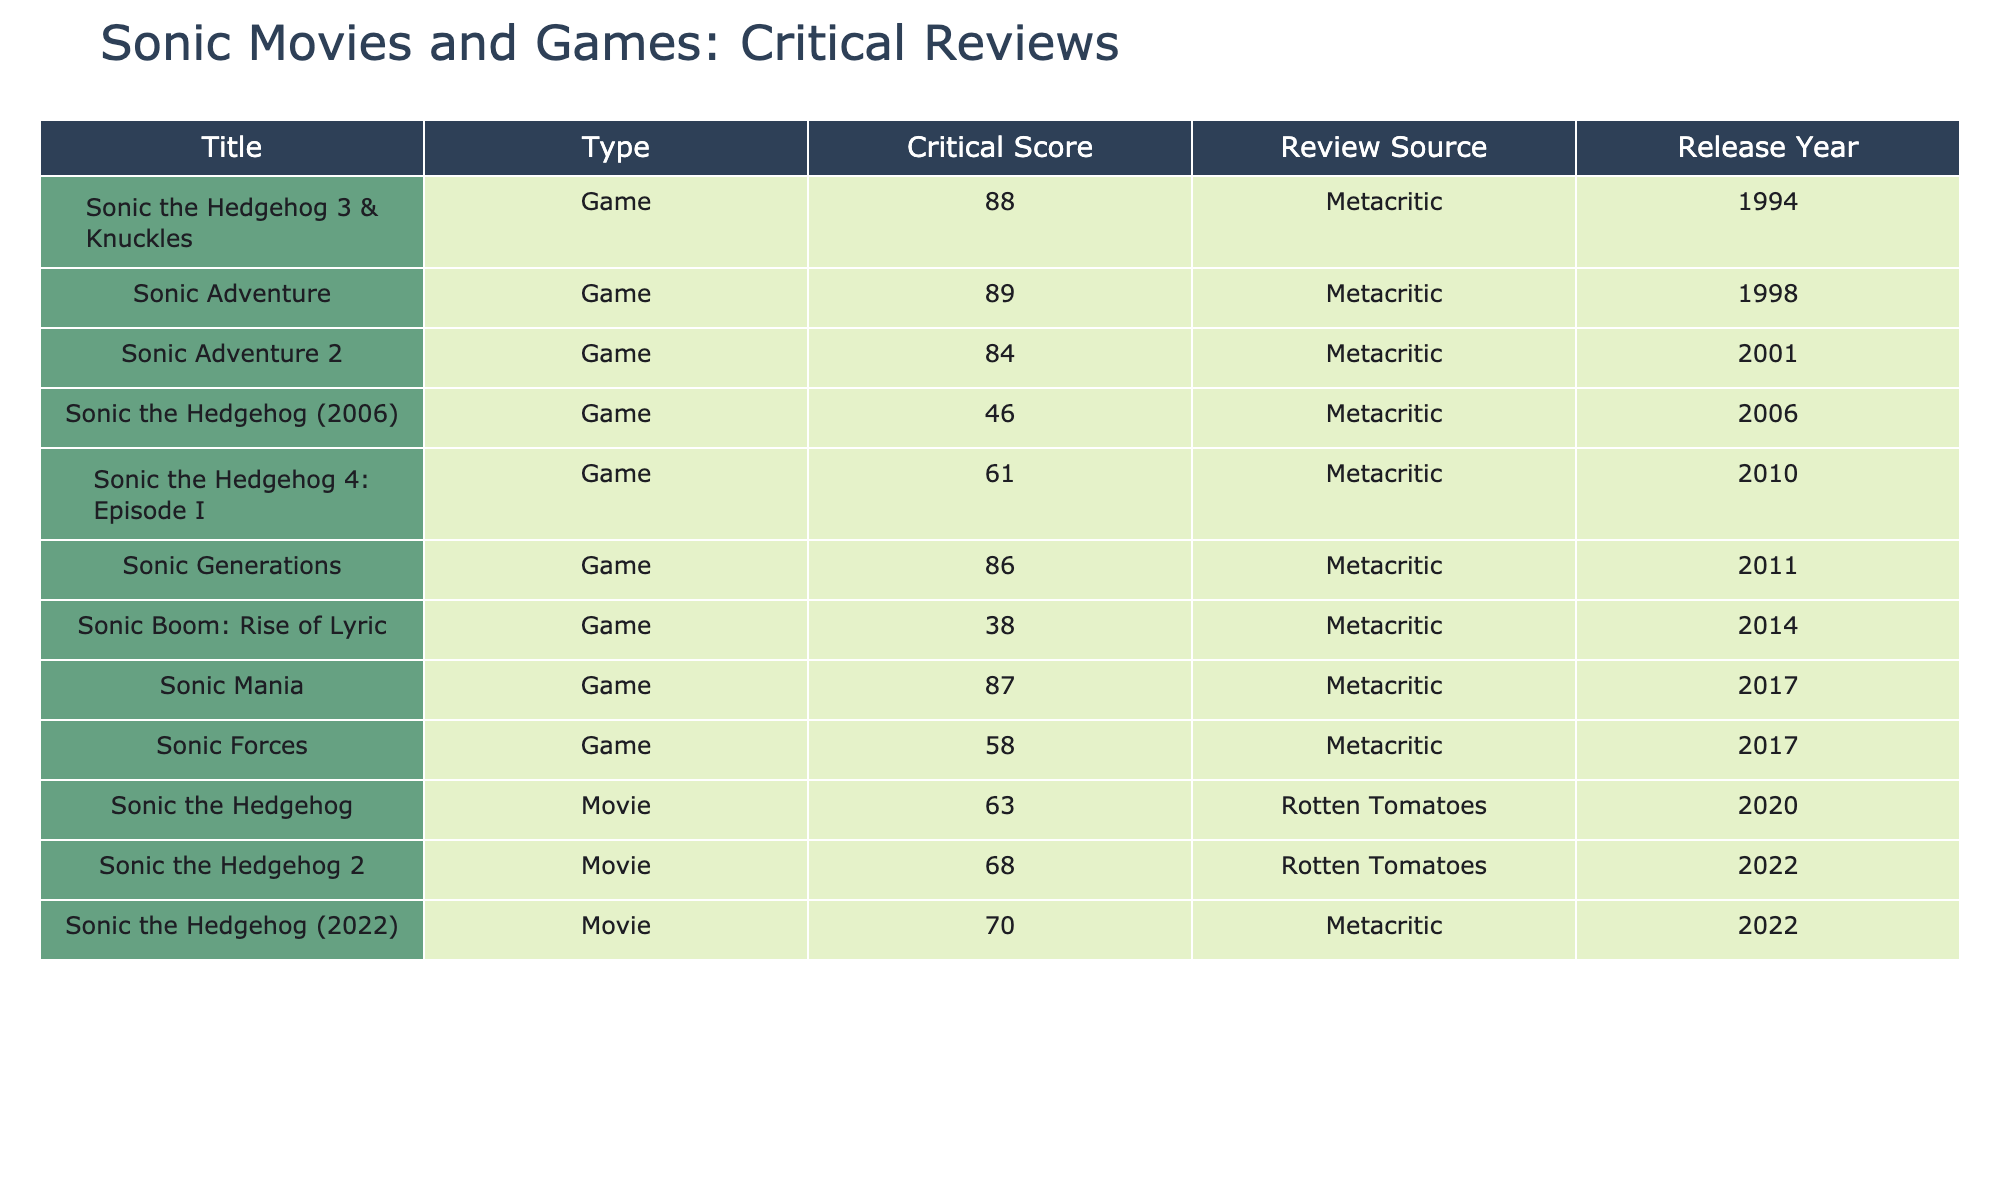What is the highest critical score among the Sonic games? The table shows the critical scores for all Sonic games. The highest score is 89 for "Sonic Adventure" (1998).
Answer: 89 Which Sonic movie received the highest score? Comparing the scores of the Sonic movies, "Sonic the Hedgehog 2" (2022) has the highest score at 68, while the other movie "Sonic the Hedgehog" (2020) has a lower score of 63.
Answer: 68 What is the average critical score of all Sonic games? The scores of the Sonic games are: 89, 84, 86, 87, 46, 58, 88, 61, 38. Adding these scores gives 89 + 84 + 86 + 87 + 46 + 58 + 88 + 61 + 38 = 597. There are 9 games, so the average is 597 / 9 ≈ 66.33.
Answer: 66.33 Is "Sonic Boom: Rise of Lyric" the lowest-rated Sonic game? The critical score for "Sonic Boom: Rise of Lyric" is 38, which is lower than all other Sonic games listed. This confirms that it is the lowest-rated game.
Answer: Yes What is the difference in critical scores between the highest-rated game and the lowest-rated game? The highest-rated game is "Sonic Adventure" with a score of 89, while the lowest-rated is "Sonic Boom: Rise of Lyric" with a score of 38. The difference is 89 - 38 = 51.
Answer: 51 Which Sonic game released in 2001 had a score below 90? The game released in 2001 is "Sonic Adventure 2," which has a critical score of 84, which is below 90.
Answer: Sonic Adventure 2 How many Sonic movies have a critical score above 65? The scores for Sonic movies are 63 and 68 for "Sonic the Hedgehog" (2020) and "Sonic the Hedgehog 2" (2022). Only "Sonic the Hedgehog 2" has a score above 65.
Answer: 1 Do any Sonic games have a critical score of exactly 61? Reviewing the scores, "Sonic the Hedgehog 4: Episode I" has a score of 61, indicating that there is a game with this exact score.
Answer: Yes What can be inferred about the trend in critical scores between Sonic movies and Sonic games? The Sonic games tend to have higher critical scores, with no scores below 38 for games while the movies have lower scores, with the highest being 68. This indicates that games generally performed better critically.
Answer: Games score higher Which Sonic title had the lowest score and what type was it? The title with the lowest score is "Sonic Boom: Rise of Lyric" with a score of 38, and it is classified as a game.
Answer: Sonic Boom: Rise of Lyric, Game 